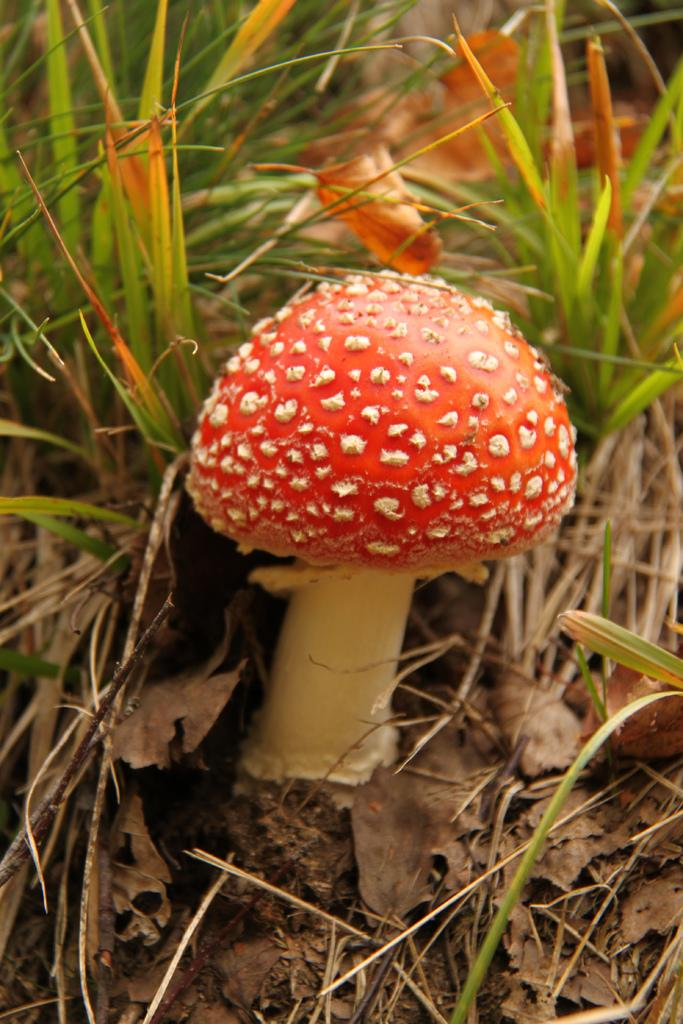What is the main subject in the image? There is a mushroom in the image. What can be seen behind the mushroom? There are dried leaves and grass behind the mushroom. What class of fear does the mushroom represent in the image? The image does not depict any fear or emotions, and there is no indication of a class of fear associated with the mushroom. 